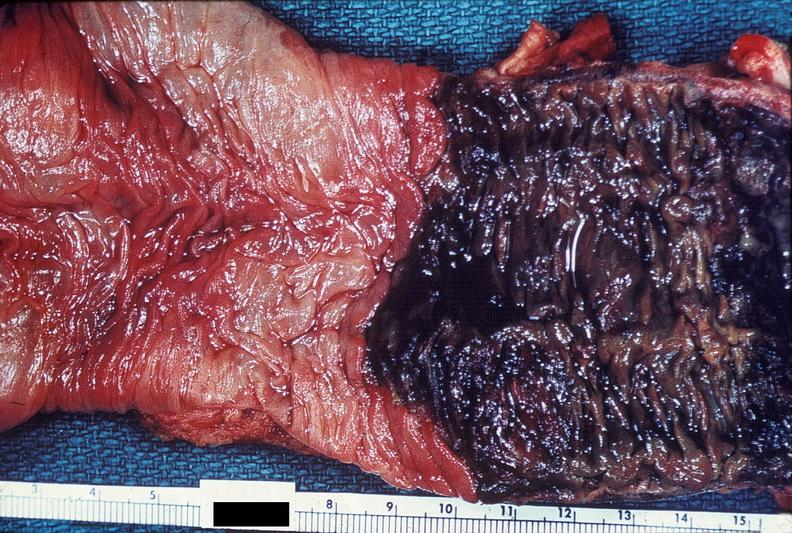does this image show colon, ischemic colitis?
Answer the question using a single word or phrase. Yes 